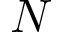<formula> <loc_0><loc_0><loc_500><loc_500>N</formula> 